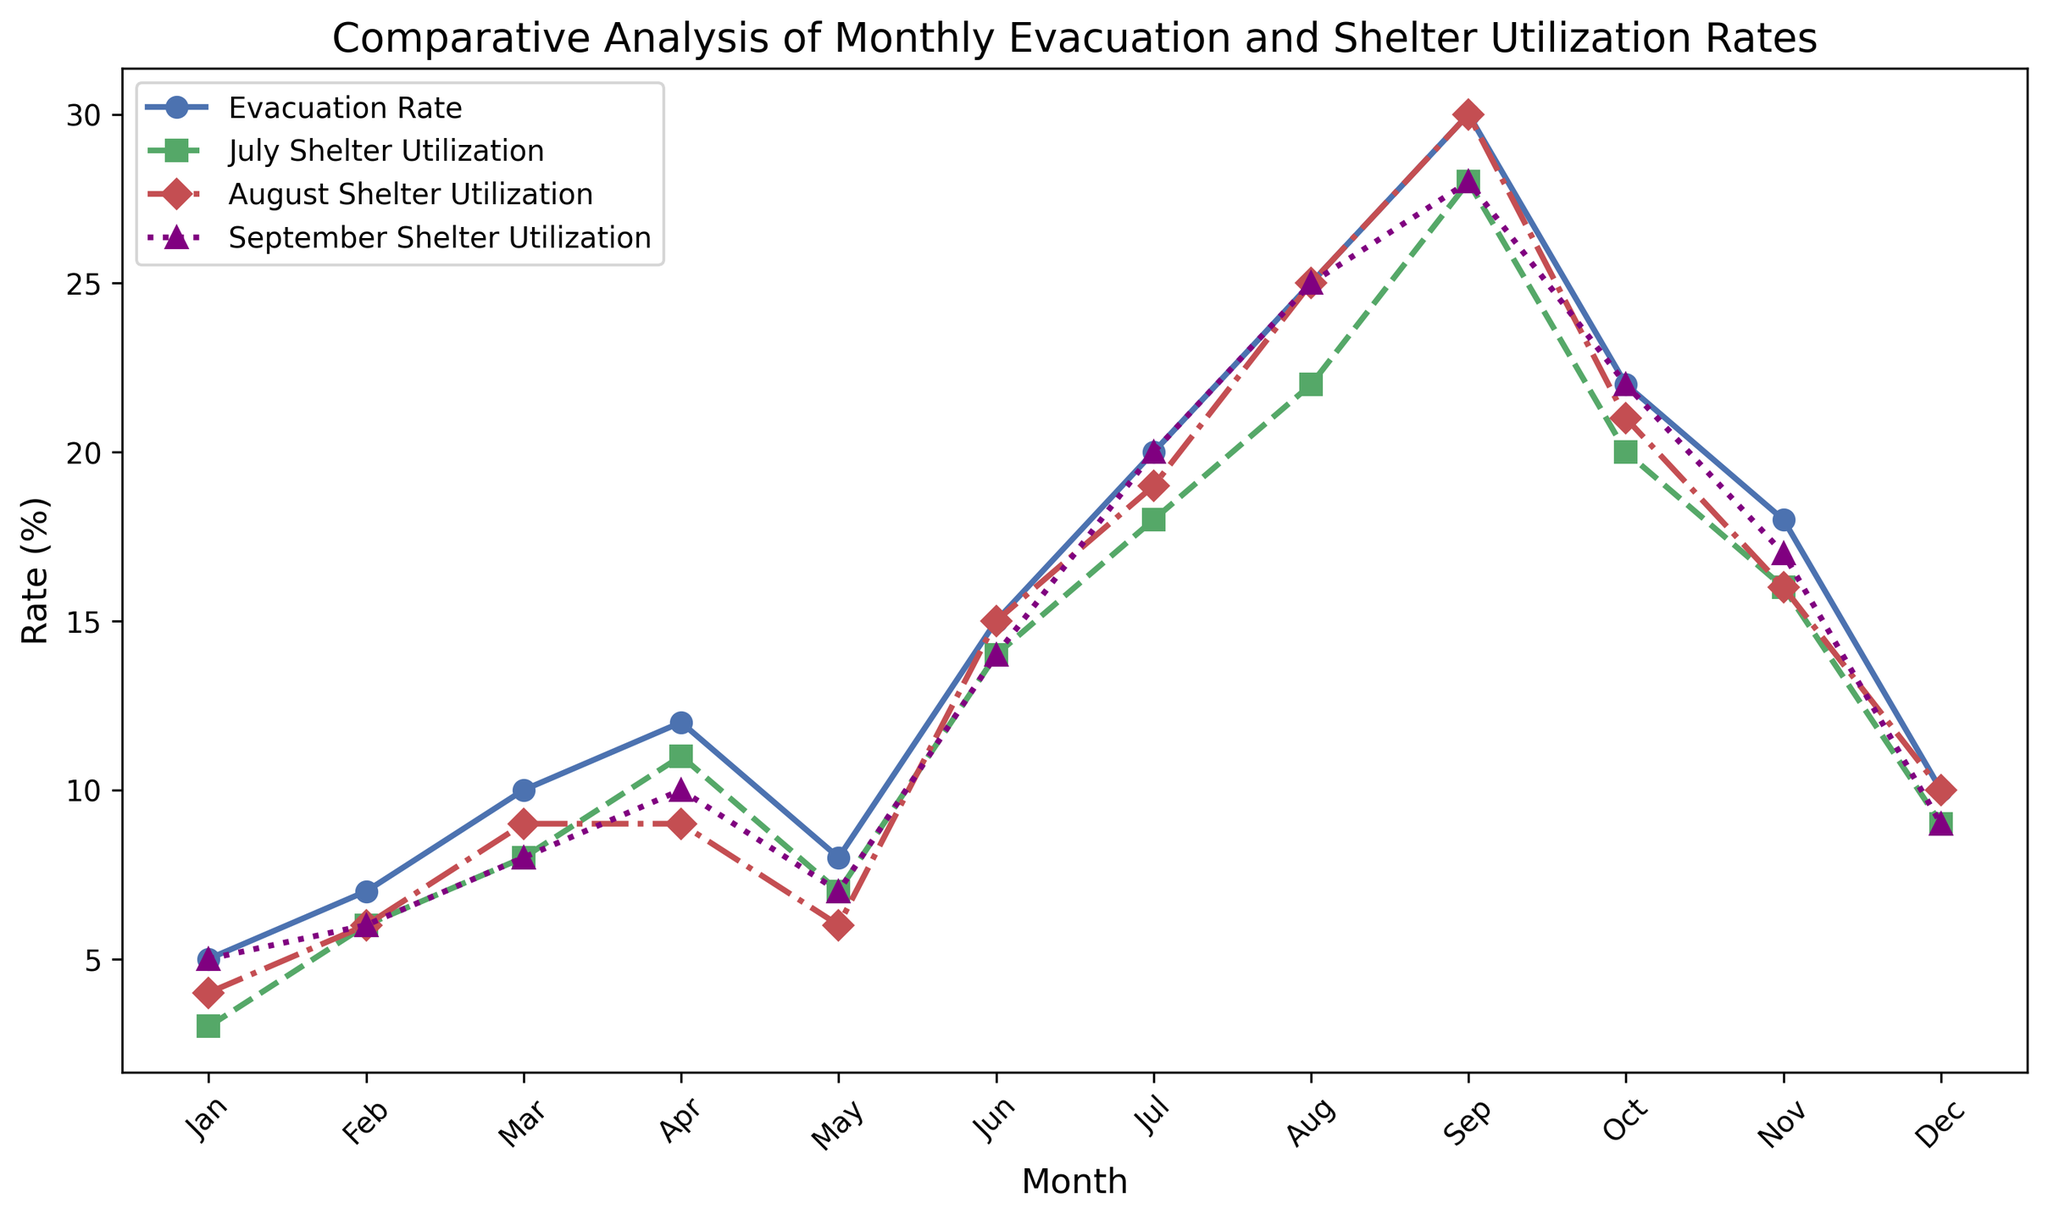How does the evacuation rate in September compare to July Shelter Utilization? The evacuation rate in September is 30%, while July Shelter Utilization in July is 18%. Hence, September's evacuation rate is higher.
Answer: September's evacuation rate is higher What is the average shelter utilization rate for August throughout the year? Add up all the August shelter utilization rates (4 + 6 + 9 + 10 + 6 + 15 + 19 + 25 + 30 + 21 + 16 + 10) and divide by 12. \( \frac{4 + 6 + 9 + 10 + 6 + 15 + 19 + 25 + 30 + 21 + 16 + 10}{12} = \frac{171}{12} = 14.25 \)
Answer: 14.25 What trend do you observe in the Evacuation Rate from January to September? By visually observing the Evacuation Rate line from January to September, it shows an upward trend, increasing almost each month.
Answer: Upward trend How does the Shelter Utilization Rate in July change from January to December? Observe the July Shelter Utilization line. It increases from 3% in January, reaches a peak of 28% in September, and then decreases back down to 9% by December.
Answer: First increases, peaks in September, then decreases What is the combined shelter utilization for July, August, and September in April? Add the shelter retention rates in April for July, August, and September. \( 11 + 9 + 10 = 30 \)
Answer: 30 Which month has the highest August Shelter Utilization rate? By observing the August Shelter Utilization line, the highest rate occurs in September at 30%.
Answer: September How does the shelter utilization for September in June compare to that of October? The shelter utilization for September is 14 in June and 22 in October. Thus, October's utilization is higher.
Answer: October's utilization is higher What is the difference between the highest and the lowest evacuation rates in the year? The highest evacuation rate is in September (30%), and the lowest is in January (5%). Thus, the difference is \( 30 - 5 = 25 \).
Answer: 25 Does the evacuation rate ever surpass the shelter utilization rates for July, August, and September in a single month? In August and September, the evacuation rate surpasses the shelter utilization rates of July, August, and September. For instance, in August: 25% (Evacuation Rate) vs. 22% (July), 25% (August), 25% (September).
Answer: Yes 